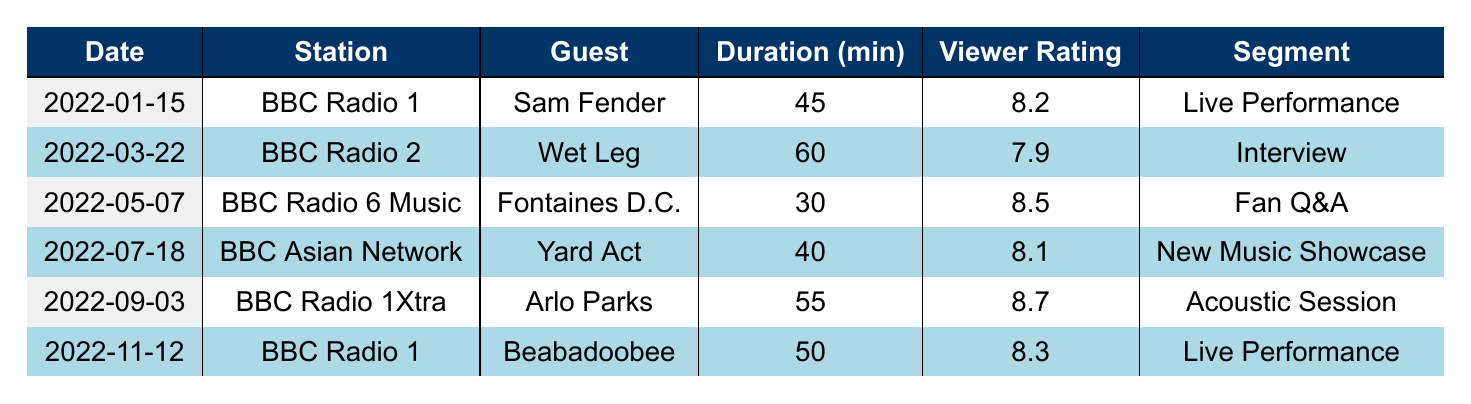What guest appeared on BBC Radio 1 on January 15, 2022? According to the table, on January 15, 2022, the guest on BBC Radio 1 was Sam Fender.
Answer: Sam Fender Which segment featured Yard Act? The table indicates that Yard Act was featured in the 'New Music Showcase' segment on July 18, 2022.
Answer: New Music Showcase What was the viewer rating for Arlo Parks' appearance? By referring to the table, Arlo Parks had a viewer rating of 8.7 on September 3, 2022.
Answer: 8.7 Which station had the longest duration for a guest appearance? Comparing the durations listed in the table, BBC Radio 2 had the longest duration of 60 minutes for Wet Leg on March 22, 2022.
Answer: BBC Radio 2 What is the total duration of Jack Saunders' guest appearances on BBC Radio 1? Based on the table, Jack Saunders had two guest appearances on BBC Radio 1 with durations of 45 minutes and 50 minutes. Thus, the total is 45 + 50 = 95 minutes.
Answer: 95 minutes How many guests had viewer ratings above 8.5? By reviewing the viewer ratings in the table, only Arlo Parks (8.7) and Fontaines D.C. (8.5) had ratings above 8.5, making it a total of two guests.
Answer: 2 Did Jack Saunders feature on BBC Asian Network more than once in 2022? The table shows that Jack Saunders only appeared once on BBC Asian Network on July 18, 2022. Therefore, the answer is NO.
Answer: No What is the average viewer rating for Jack Saunders' guest appearances listed in the table? To find the average, sum all the viewer ratings (8.2 + 7.9 + 8.5 + 8.1 + 8.7 + 8.3) = 49.7, then divide by the number of appearances (6): 49.7 / 6 = 8.2833, which approximates to 8.3.
Answer: 8.3 Which guest appeared for the shortest duration, and how long was it? From examining the durations in the table, Fontaines D.C. had the shortest duration of 30 minutes during their guest appearance on BBC Radio 6 Music.
Answer: Fontaines D.C., 30 minutes What was the most common segment type for the guest appearances? Analyzing the segments in the table, 'Live Performance' is the most common segment, as it appears twice (with Sam Fender and Beabadoobee).
Answer: Live Performance 